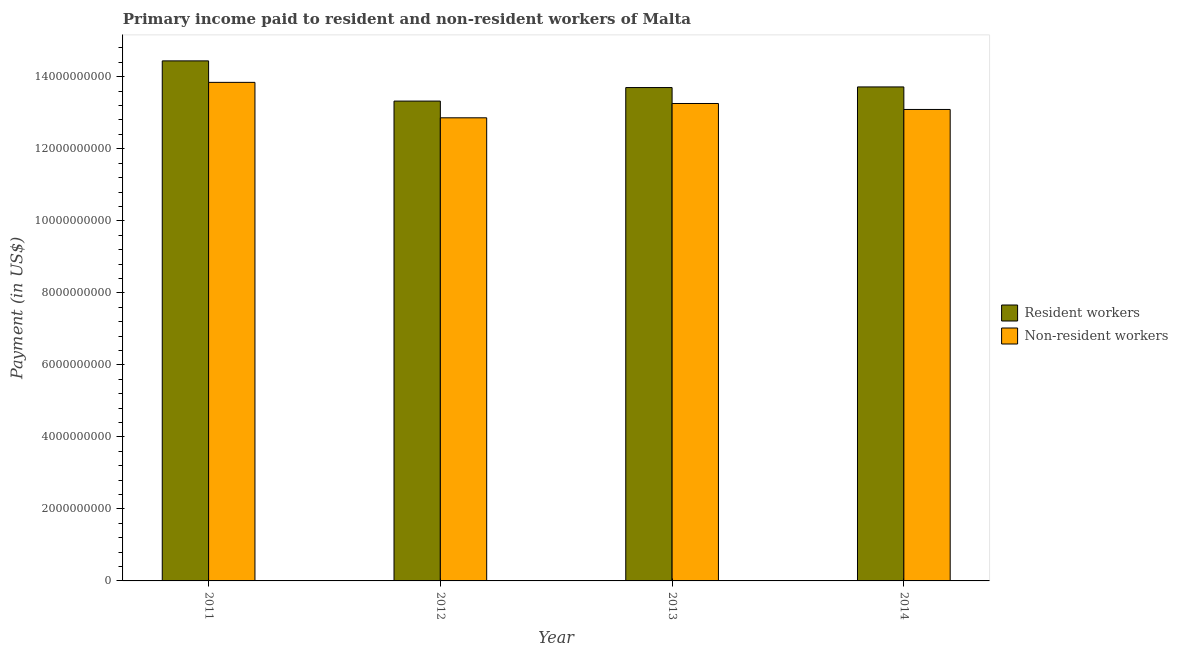How many groups of bars are there?
Your answer should be compact. 4. Are the number of bars per tick equal to the number of legend labels?
Ensure brevity in your answer.  Yes. How many bars are there on the 1st tick from the left?
Your answer should be compact. 2. What is the label of the 4th group of bars from the left?
Your answer should be compact. 2014. In how many cases, is the number of bars for a given year not equal to the number of legend labels?
Provide a succinct answer. 0. What is the payment made to non-resident workers in 2014?
Give a very brief answer. 1.31e+1. Across all years, what is the maximum payment made to resident workers?
Make the answer very short. 1.44e+1. Across all years, what is the minimum payment made to resident workers?
Keep it short and to the point. 1.33e+1. What is the total payment made to resident workers in the graph?
Offer a terse response. 5.52e+1. What is the difference between the payment made to non-resident workers in 2011 and that in 2014?
Keep it short and to the point. 7.53e+08. What is the difference between the payment made to non-resident workers in 2013 and the payment made to resident workers in 2011?
Ensure brevity in your answer.  -5.87e+08. What is the average payment made to resident workers per year?
Offer a very short reply. 1.38e+1. What is the ratio of the payment made to resident workers in 2011 to that in 2012?
Ensure brevity in your answer.  1.08. Is the payment made to non-resident workers in 2011 less than that in 2012?
Give a very brief answer. No. Is the difference between the payment made to non-resident workers in 2011 and 2013 greater than the difference between the payment made to resident workers in 2011 and 2013?
Keep it short and to the point. No. What is the difference between the highest and the second highest payment made to resident workers?
Ensure brevity in your answer.  7.23e+08. What is the difference between the highest and the lowest payment made to resident workers?
Your response must be concise. 1.12e+09. In how many years, is the payment made to resident workers greater than the average payment made to resident workers taken over all years?
Keep it short and to the point. 1. What does the 2nd bar from the left in 2011 represents?
Give a very brief answer. Non-resident workers. What does the 2nd bar from the right in 2014 represents?
Provide a short and direct response. Resident workers. How many bars are there?
Your response must be concise. 8. Are all the bars in the graph horizontal?
Offer a terse response. No. How many years are there in the graph?
Offer a terse response. 4. What is the difference between two consecutive major ticks on the Y-axis?
Your response must be concise. 2.00e+09. Are the values on the major ticks of Y-axis written in scientific E-notation?
Give a very brief answer. No. Where does the legend appear in the graph?
Offer a terse response. Center right. How many legend labels are there?
Provide a succinct answer. 2. What is the title of the graph?
Give a very brief answer. Primary income paid to resident and non-resident workers of Malta. What is the label or title of the Y-axis?
Offer a terse response. Payment (in US$). What is the Payment (in US$) in Resident workers in 2011?
Provide a short and direct response. 1.44e+1. What is the Payment (in US$) of Non-resident workers in 2011?
Your response must be concise. 1.38e+1. What is the Payment (in US$) of Resident workers in 2012?
Your answer should be very brief. 1.33e+1. What is the Payment (in US$) of Non-resident workers in 2012?
Provide a short and direct response. 1.29e+1. What is the Payment (in US$) in Resident workers in 2013?
Ensure brevity in your answer.  1.37e+1. What is the Payment (in US$) in Non-resident workers in 2013?
Ensure brevity in your answer.  1.33e+1. What is the Payment (in US$) in Resident workers in 2014?
Your response must be concise. 1.37e+1. What is the Payment (in US$) in Non-resident workers in 2014?
Make the answer very short. 1.31e+1. Across all years, what is the maximum Payment (in US$) of Resident workers?
Provide a short and direct response. 1.44e+1. Across all years, what is the maximum Payment (in US$) in Non-resident workers?
Offer a terse response. 1.38e+1. Across all years, what is the minimum Payment (in US$) in Resident workers?
Your response must be concise. 1.33e+1. Across all years, what is the minimum Payment (in US$) in Non-resident workers?
Offer a terse response. 1.29e+1. What is the total Payment (in US$) of Resident workers in the graph?
Your response must be concise. 5.52e+1. What is the total Payment (in US$) of Non-resident workers in the graph?
Offer a terse response. 5.31e+1. What is the difference between the Payment (in US$) of Resident workers in 2011 and that in 2012?
Offer a very short reply. 1.12e+09. What is the difference between the Payment (in US$) of Non-resident workers in 2011 and that in 2012?
Provide a succinct answer. 9.84e+08. What is the difference between the Payment (in US$) in Resident workers in 2011 and that in 2013?
Offer a terse response. 7.41e+08. What is the difference between the Payment (in US$) of Non-resident workers in 2011 and that in 2013?
Your response must be concise. 5.87e+08. What is the difference between the Payment (in US$) in Resident workers in 2011 and that in 2014?
Provide a short and direct response. 7.23e+08. What is the difference between the Payment (in US$) of Non-resident workers in 2011 and that in 2014?
Offer a very short reply. 7.53e+08. What is the difference between the Payment (in US$) in Resident workers in 2012 and that in 2013?
Your answer should be very brief. -3.76e+08. What is the difference between the Payment (in US$) of Non-resident workers in 2012 and that in 2013?
Offer a very short reply. -3.98e+08. What is the difference between the Payment (in US$) in Resident workers in 2012 and that in 2014?
Give a very brief answer. -3.93e+08. What is the difference between the Payment (in US$) of Non-resident workers in 2012 and that in 2014?
Ensure brevity in your answer.  -2.32e+08. What is the difference between the Payment (in US$) in Resident workers in 2013 and that in 2014?
Ensure brevity in your answer.  -1.76e+07. What is the difference between the Payment (in US$) in Non-resident workers in 2013 and that in 2014?
Give a very brief answer. 1.66e+08. What is the difference between the Payment (in US$) in Resident workers in 2011 and the Payment (in US$) in Non-resident workers in 2012?
Ensure brevity in your answer.  1.58e+09. What is the difference between the Payment (in US$) of Resident workers in 2011 and the Payment (in US$) of Non-resident workers in 2013?
Make the answer very short. 1.18e+09. What is the difference between the Payment (in US$) in Resident workers in 2011 and the Payment (in US$) in Non-resident workers in 2014?
Your answer should be very brief. 1.35e+09. What is the difference between the Payment (in US$) in Resident workers in 2012 and the Payment (in US$) in Non-resident workers in 2013?
Offer a terse response. 6.68e+07. What is the difference between the Payment (in US$) in Resident workers in 2012 and the Payment (in US$) in Non-resident workers in 2014?
Offer a very short reply. 2.33e+08. What is the difference between the Payment (in US$) of Resident workers in 2013 and the Payment (in US$) of Non-resident workers in 2014?
Offer a terse response. 6.08e+08. What is the average Payment (in US$) in Resident workers per year?
Provide a short and direct response. 1.38e+1. What is the average Payment (in US$) of Non-resident workers per year?
Ensure brevity in your answer.  1.33e+1. In the year 2011, what is the difference between the Payment (in US$) in Resident workers and Payment (in US$) in Non-resident workers?
Give a very brief answer. 5.97e+08. In the year 2012, what is the difference between the Payment (in US$) of Resident workers and Payment (in US$) of Non-resident workers?
Ensure brevity in your answer.  4.64e+08. In the year 2013, what is the difference between the Payment (in US$) of Resident workers and Payment (in US$) of Non-resident workers?
Provide a succinct answer. 4.42e+08. In the year 2014, what is the difference between the Payment (in US$) in Resident workers and Payment (in US$) in Non-resident workers?
Offer a terse response. 6.26e+08. What is the ratio of the Payment (in US$) in Resident workers in 2011 to that in 2012?
Offer a very short reply. 1.08. What is the ratio of the Payment (in US$) in Non-resident workers in 2011 to that in 2012?
Keep it short and to the point. 1.08. What is the ratio of the Payment (in US$) in Resident workers in 2011 to that in 2013?
Your answer should be compact. 1.05. What is the ratio of the Payment (in US$) of Non-resident workers in 2011 to that in 2013?
Make the answer very short. 1.04. What is the ratio of the Payment (in US$) in Resident workers in 2011 to that in 2014?
Offer a very short reply. 1.05. What is the ratio of the Payment (in US$) in Non-resident workers in 2011 to that in 2014?
Offer a terse response. 1.06. What is the ratio of the Payment (in US$) in Resident workers in 2012 to that in 2013?
Keep it short and to the point. 0.97. What is the ratio of the Payment (in US$) in Non-resident workers in 2012 to that in 2013?
Give a very brief answer. 0.97. What is the ratio of the Payment (in US$) in Resident workers in 2012 to that in 2014?
Keep it short and to the point. 0.97. What is the ratio of the Payment (in US$) in Non-resident workers in 2012 to that in 2014?
Your answer should be compact. 0.98. What is the ratio of the Payment (in US$) in Non-resident workers in 2013 to that in 2014?
Ensure brevity in your answer.  1.01. What is the difference between the highest and the second highest Payment (in US$) of Resident workers?
Your answer should be compact. 7.23e+08. What is the difference between the highest and the second highest Payment (in US$) of Non-resident workers?
Ensure brevity in your answer.  5.87e+08. What is the difference between the highest and the lowest Payment (in US$) in Resident workers?
Your response must be concise. 1.12e+09. What is the difference between the highest and the lowest Payment (in US$) in Non-resident workers?
Provide a succinct answer. 9.84e+08. 